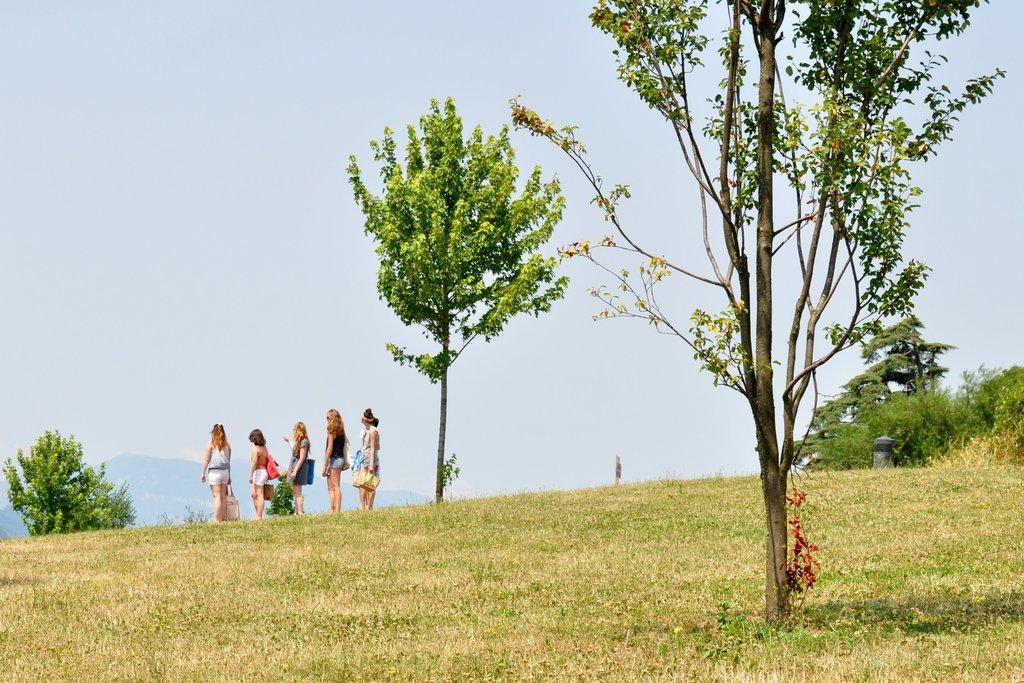What type of vegetation is present in the image? There is grass in the image. What other natural elements can be seen in the image? There are trees in the image. Are there any human subjects in the image? Yes, there are people standing in the image. What is visible at the top of the image? The sky is visible at the top of the image. What type of fowl can be seen flying in the image? There is no fowl present in the image; it only features grass, trees, people, and the sky. Can you tell me how many sails are visible in the image? There are no sails present in the image; it does not depict any boats or water-related elements. 